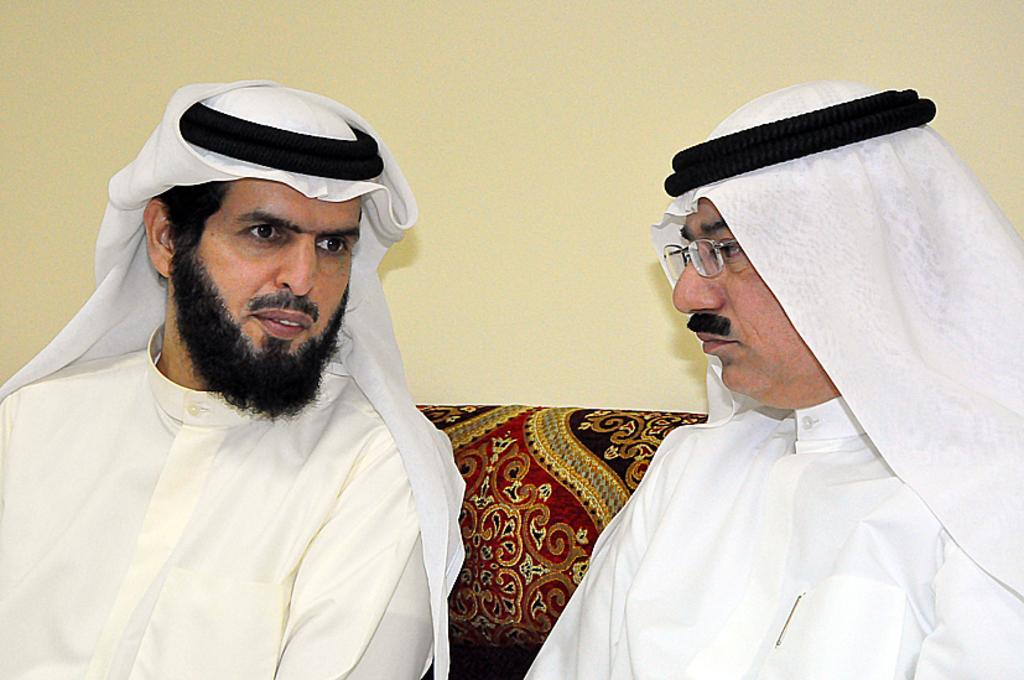How many people are in the image? There are two men in the image. What are the men doing in the image? Both men are sitting. Are the men wearing any clothing? Yes, both men are wearing clothes. Can you describe the appearance of the man on the right side? The right side man is wearing spectacles. What can be seen in the background of the image? There is a wall visible in the image. What type of giraffe can be seen in the image? There is no giraffe present in the image. How much was the payment for the service provided by the men in the image? There is no information about payment in the image. 